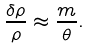Convert formula to latex. <formula><loc_0><loc_0><loc_500><loc_500>\frac { \delta \rho } { \rho } \approx \frac { m } { \theta } .</formula> 